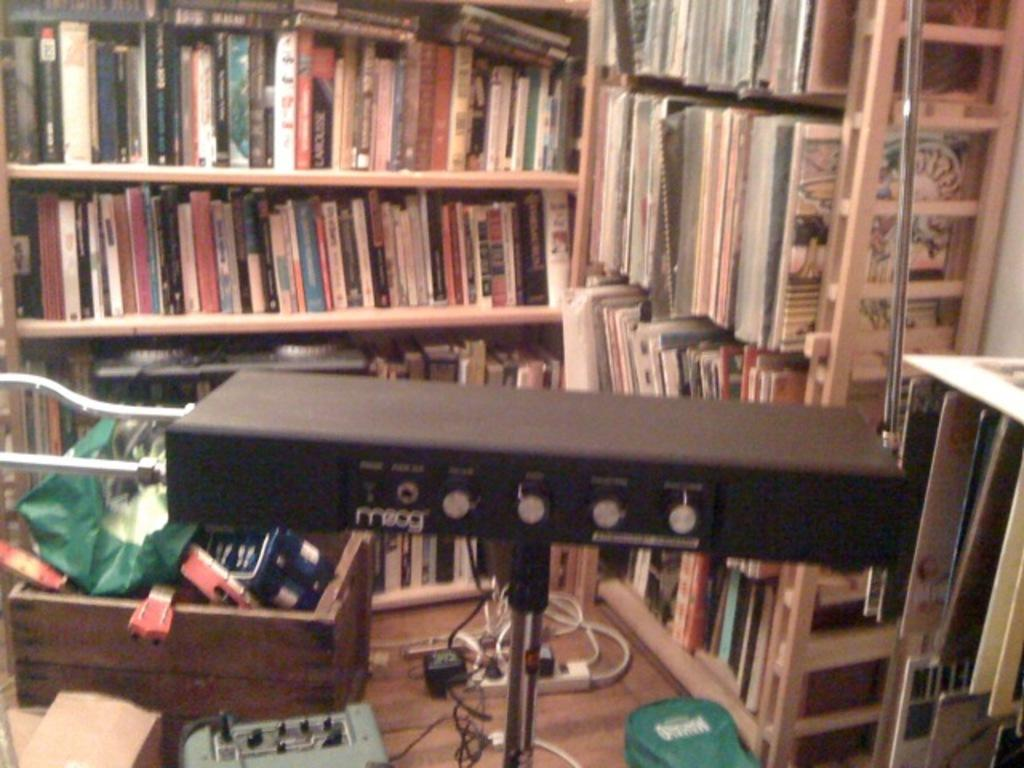What is the main object in the image? There is a big bookshelf in the image. What is stored on the bookshelf? The bookshelf is filled with books. What can be seen at the bottom of the image? There is a box, items, wires, and rods visible at the bottom of the image. What is the color of the object mentioned in the image? There is a black color object in the image. Can you see the father sitting on a boat in the image? There is no father or boat present in the image. Where is the seat located in the image? There is no seat mentioned or visible in the image. 